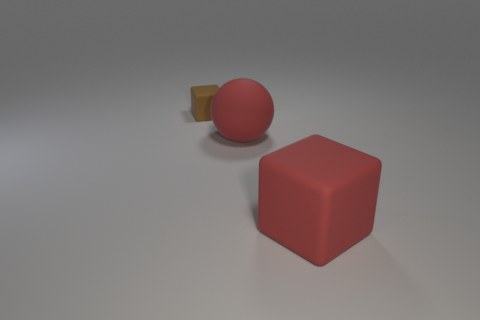Can you tell me the shapes and colors of the objects in the image? Certainly! In the image, there is one red sphere, one red cube, and a yellow object that resembles a wedge or a cut sphere. The shapes are distinctly geometric, and the colors are vivid and easily distinguishable. 